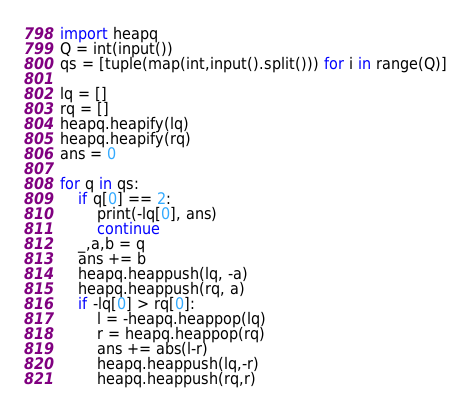<code> <loc_0><loc_0><loc_500><loc_500><_Python_>import heapq
Q = int(input())
qs = [tuple(map(int,input().split())) for i in range(Q)]

lq = []
rq = []
heapq.heapify(lq)
heapq.heapify(rq)
ans = 0

for q in qs:
    if q[0] == 2:
        print(-lq[0], ans)
        continue
    _,a,b = q
    ans += b
    heapq.heappush(lq, -a)
    heapq.heappush(rq, a)
    if -lq[0] > rq[0]:
        l = -heapq.heappop(lq)
        r = heapq.heappop(rq)
        ans += abs(l-r)
        heapq.heappush(lq,-r)
        heapq.heappush(rq,r)</code> 